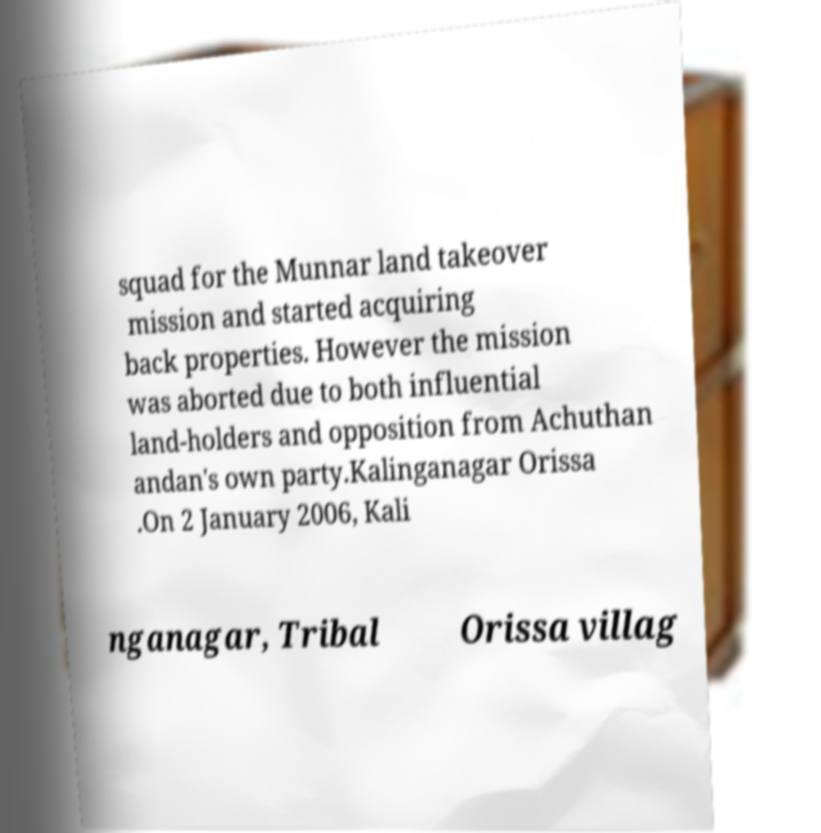For documentation purposes, I need the text within this image transcribed. Could you provide that? squad for the Munnar land takeover mission and started acquiring back properties. However the mission was aborted due to both influential land-holders and opposition from Achuthan andan's own party.Kalinganagar Orissa .On 2 January 2006, Kali nganagar, Tribal Orissa villag 